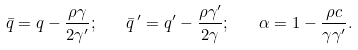Convert formula to latex. <formula><loc_0><loc_0><loc_500><loc_500>\bar { q } = q - \frac { \rho \gamma } { 2 \gamma ^ { \prime } } ; \quad \bar { q } \, ^ { \prime } = q ^ { \prime } - \frac { \rho \gamma ^ { \prime } } { 2 \gamma } ; \quad \alpha = 1 - \frac { \rho c } { \gamma \gamma ^ { \prime } } .</formula> 